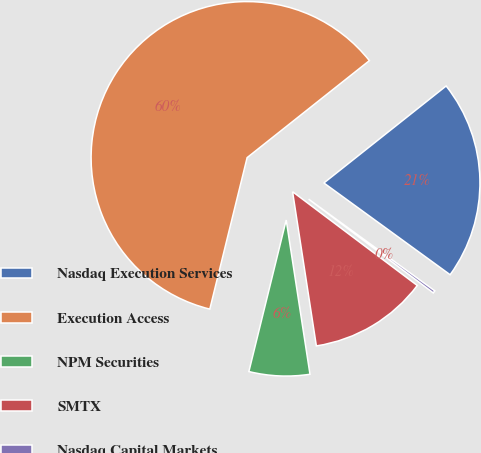Convert chart to OTSL. <chart><loc_0><loc_0><loc_500><loc_500><pie_chart><fcel>Nasdaq Execution Services<fcel>Execution Access<fcel>NPM Securities<fcel>SMTX<fcel>Nasdaq Capital Markets<nl><fcel>20.68%<fcel>60.48%<fcel>6.28%<fcel>12.3%<fcel>0.26%<nl></chart> 